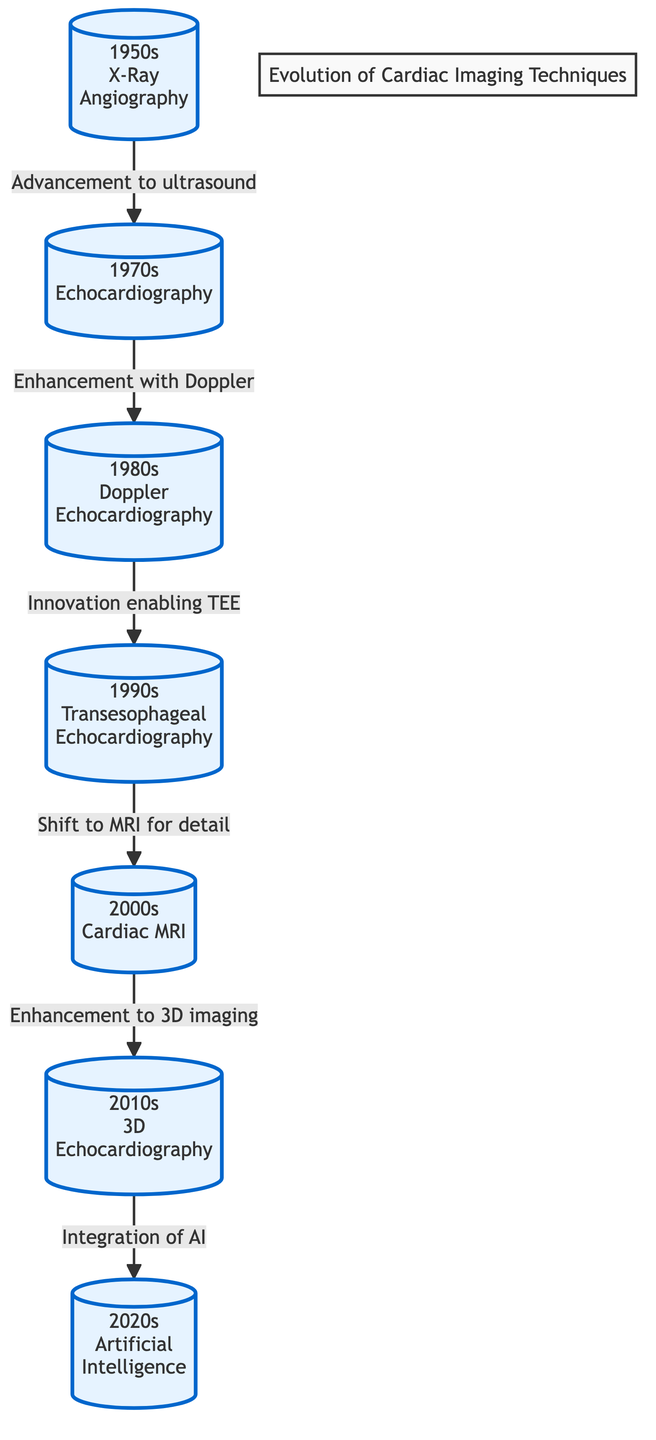What was the first imaging technique developed in the 1950s? The diagram clearly shows that the first imaging technique listed for the 1950s is "X-Ray Angiography." This can be identified by locating the node labeled for the 1950s in the flowchart.
Answer: X-Ray Angiography How many key imaging techniques are shown in the diagram? By counting the nodes in the flowchart, there are a total of seven imaging techniques represented. These are each from the respective decades listed, making it straightforward to enumerate them.
Answer: 7 Which decade saw the introduction of Cardiac MRI? The node labeled "Cardiac MRI" is positioned in the 2000s section of the diagram, indicating that this technique was introduced during that decade.
Answer: 2000s What advancement connects Echocardiography to Doppler Echocardiography? The diagram indicates a directional arrow connecting the "Echocardiography" node to the "Doppler Echocardiography" node, with the label "Enhancement with Doppler," describing the relationship.
Answer: Enhancement with Doppler What is the relationship between Transesophageal Echocardiography and Cardiac MRI? The diagram shows that Transesophageal Echocardiography is followed by an arrow leading to Cardiac MRI, labeled "Shift to MRI for detail." This indicates the evolution of imaging techniques from one to the other highlights a transition focusing on increased detail through MRI technology.
Answer: Shift to MRI for detail What connections exist between the 2010s and 2020s in the diagram? The flowchart depicts a connection between 3D Echocardiography in the 2010s and Artificial Intelligence in the 2020s, marked by the label "Integration of AI." This indicates that advancements in AI were built on previous developments in echocardiography.
Answer: Integration of AI Which imaging technique corresponds with the 1980s? Simply referring to the corresponding section in the diagram, the imaging technique that represents the 1980s is "Doppler Echocardiography." This can be identified visually in the flowchart around that decade.
Answer: Doppler Echocardiography What decade marks the emergence of Artificial Intelligence in cardiac imaging? The diagram positions "Artificial Intelligence" under the 2020s, indicating this decade marks its emergence in the field of cardiac imaging techniques.
Answer: 2020s 